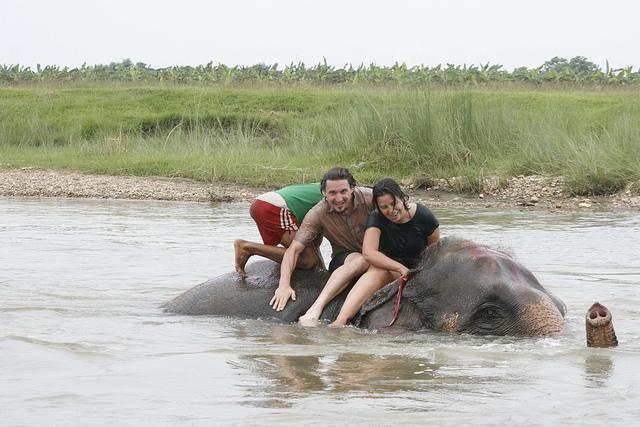How many people are in the photo?
Give a very brief answer. 3. 